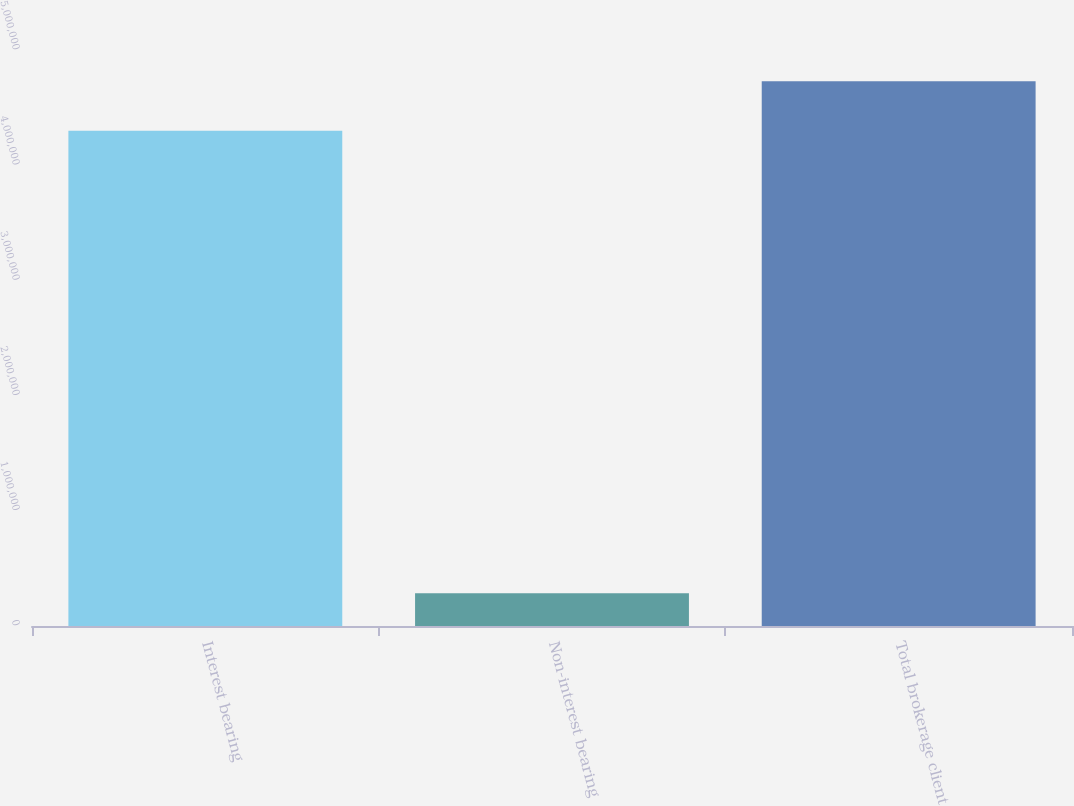<chart> <loc_0><loc_0><loc_500><loc_500><bar_chart><fcel>Interest bearing<fcel>Non-interest bearing<fcel>Total brokerage client<nl><fcel>4.29964e+06<fcel>285016<fcel>4.7296e+06<nl></chart> 